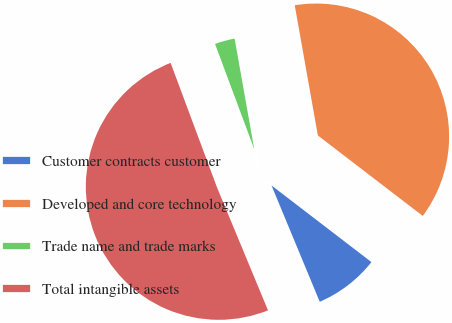<chart> <loc_0><loc_0><loc_500><loc_500><pie_chart><fcel>Customer contracts customer<fcel>Developed and core technology<fcel>Trade name and trade marks<fcel>Total intangible assets<nl><fcel>8.33%<fcel>38.21%<fcel>2.88%<fcel>50.58%<nl></chart> 